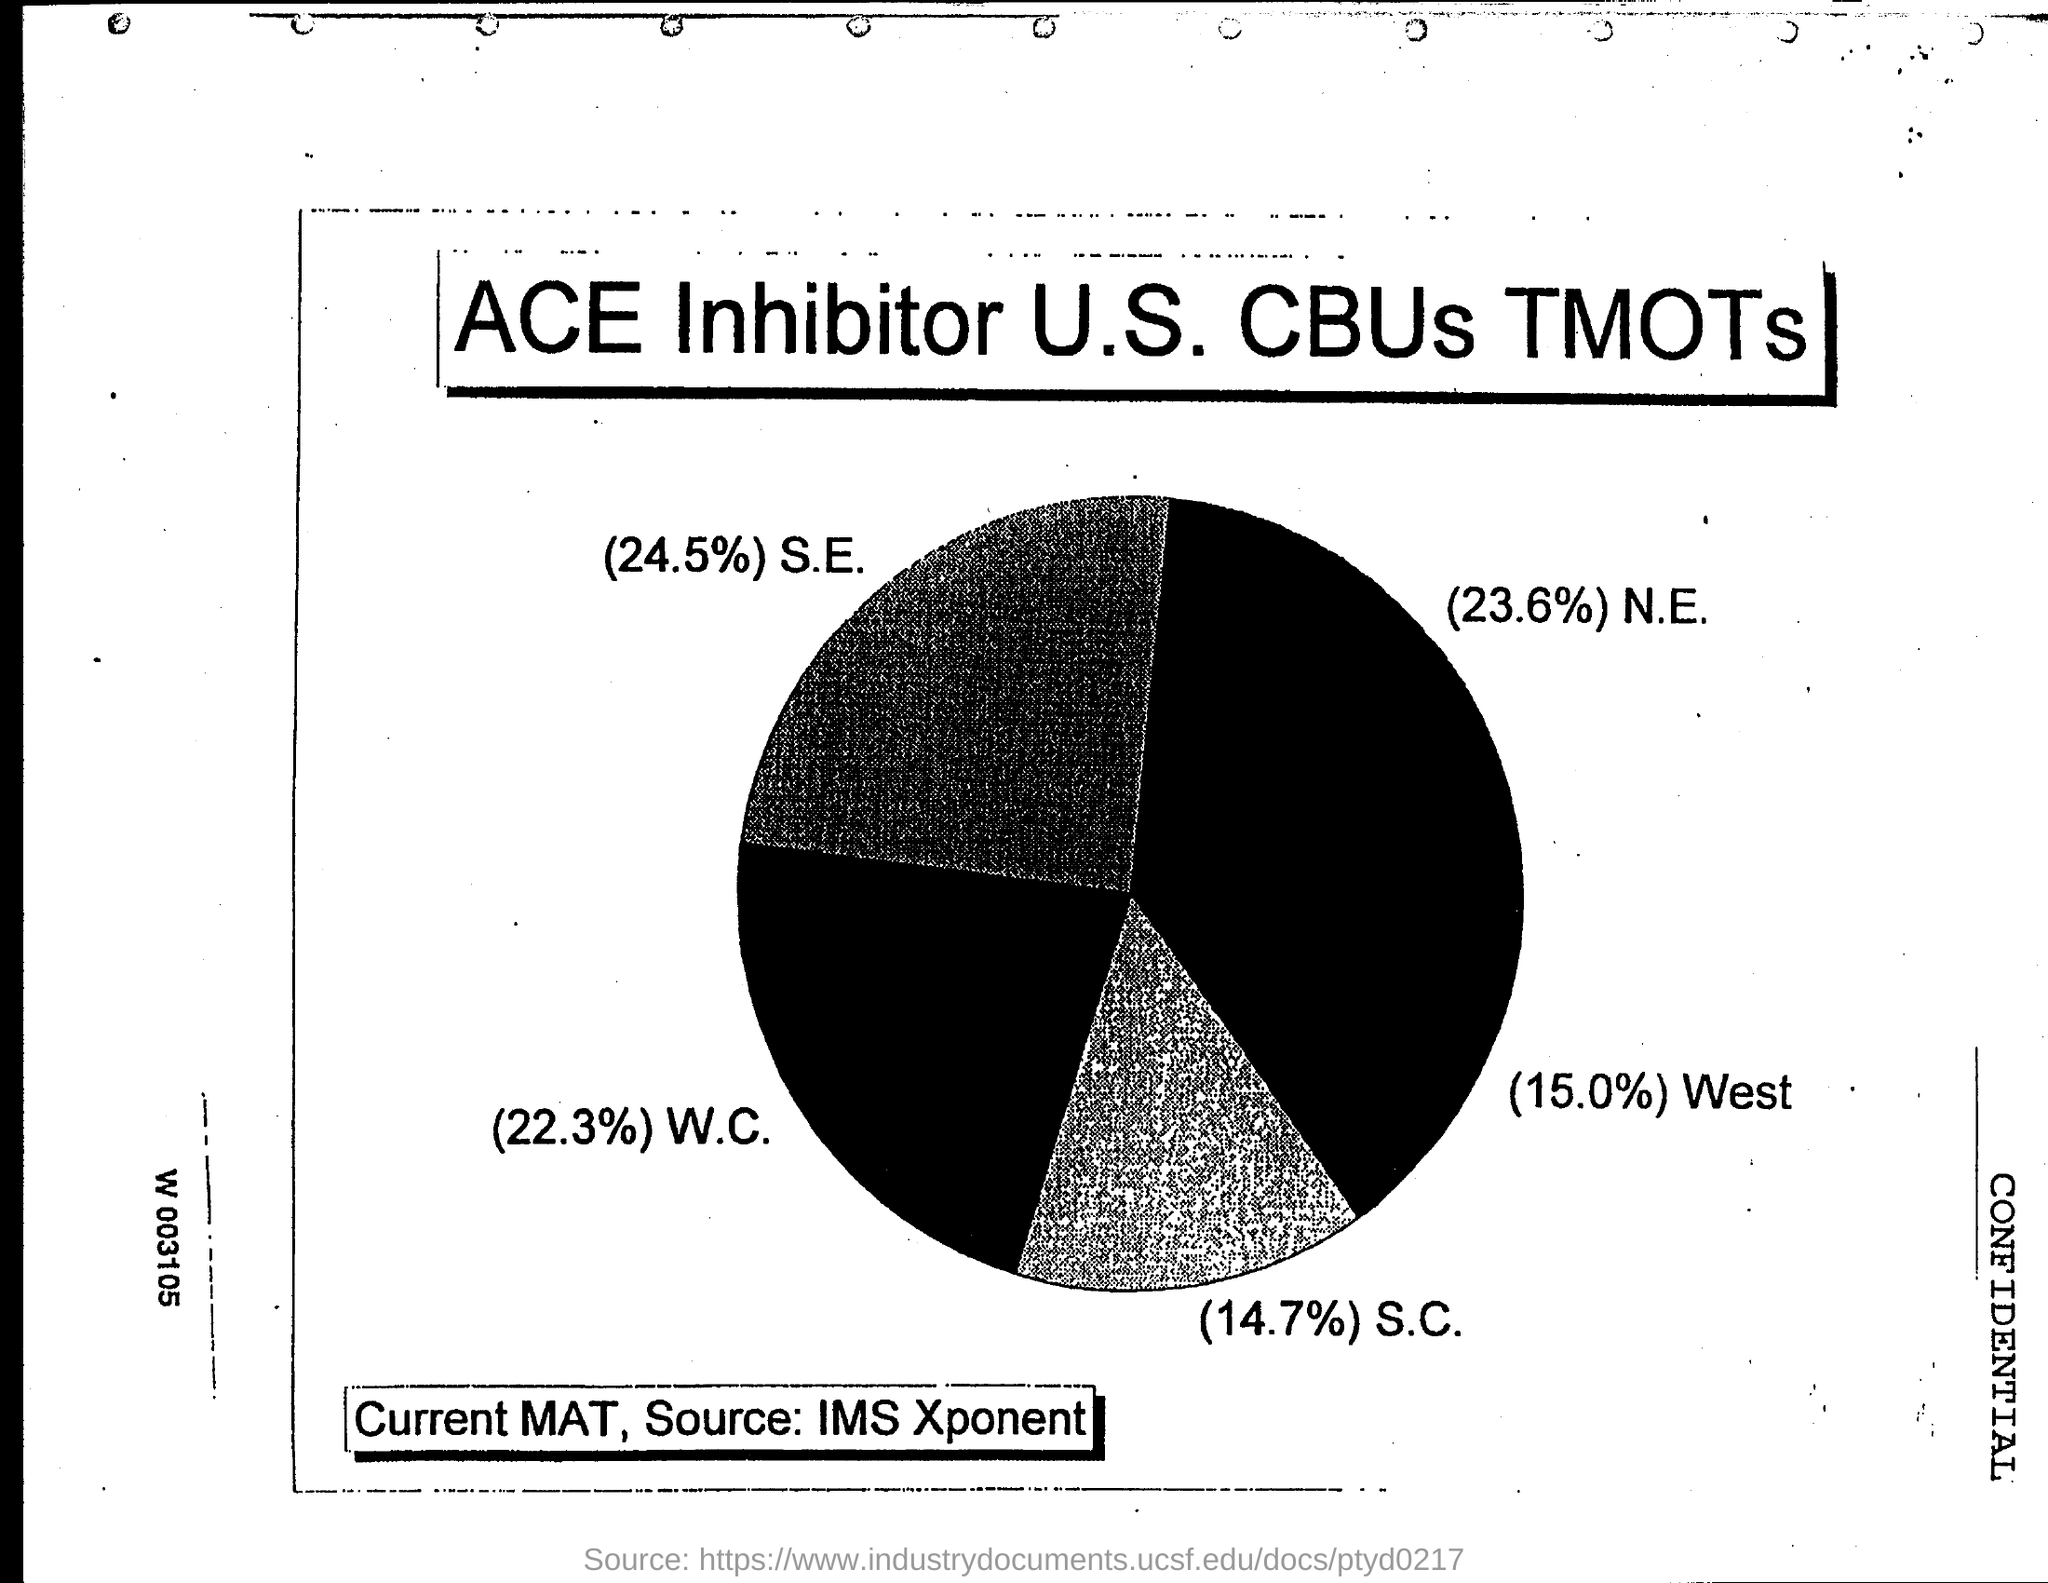What is the percentage of s.c?
Your answer should be compact. 14.7%. What is the percentage of s.e?
Provide a succinct answer. 24.5%. What is the percentage of n.e.?
Make the answer very short. 23.6%. What is the percentage of w.c.?
Make the answer very short. 22.3%. What is the percentage of west ?
Provide a short and direct response. 15.0%. 